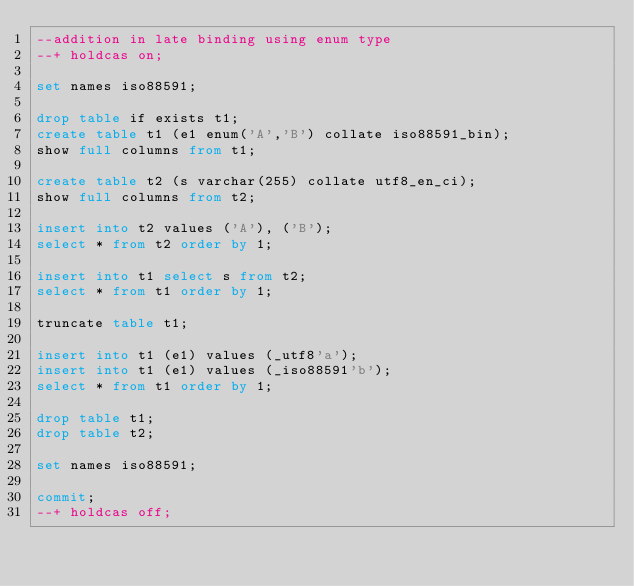Convert code to text. <code><loc_0><loc_0><loc_500><loc_500><_SQL_>--addition in late binding using enum type
--+ holdcas on;

set names iso88591;

drop table if exists t1;
create table t1 (e1 enum('A','B') collate iso88591_bin);
show full columns from t1;

create table t2 (s varchar(255) collate utf8_en_ci);
show full columns from t2;

insert into t2 values ('A'), ('B');
select * from t2 order by 1;

insert into t1 select s from t2;
select * from t1 order by 1;

truncate table t1;

insert into t1 (e1) values (_utf8'a');
insert into t1 (e1) values (_iso88591'b');
select * from t1 order by 1;

drop table t1;
drop table t2;

set names iso88591;

commit;
--+ holdcas off;
</code> 